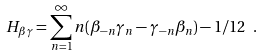<formula> <loc_0><loc_0><loc_500><loc_500>H _ { \beta \gamma } = \sum _ { n = 1 } ^ { \infty } n ( \beta _ { - n } \gamma _ { n } - \gamma _ { - n } \beta _ { n } ) - 1 / 1 2 \ .</formula> 